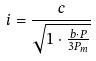<formula> <loc_0><loc_0><loc_500><loc_500>i = \frac { c } { \sqrt { 1 \cdot \frac { b \cdot P } { 3 P _ { m } } } }</formula> 